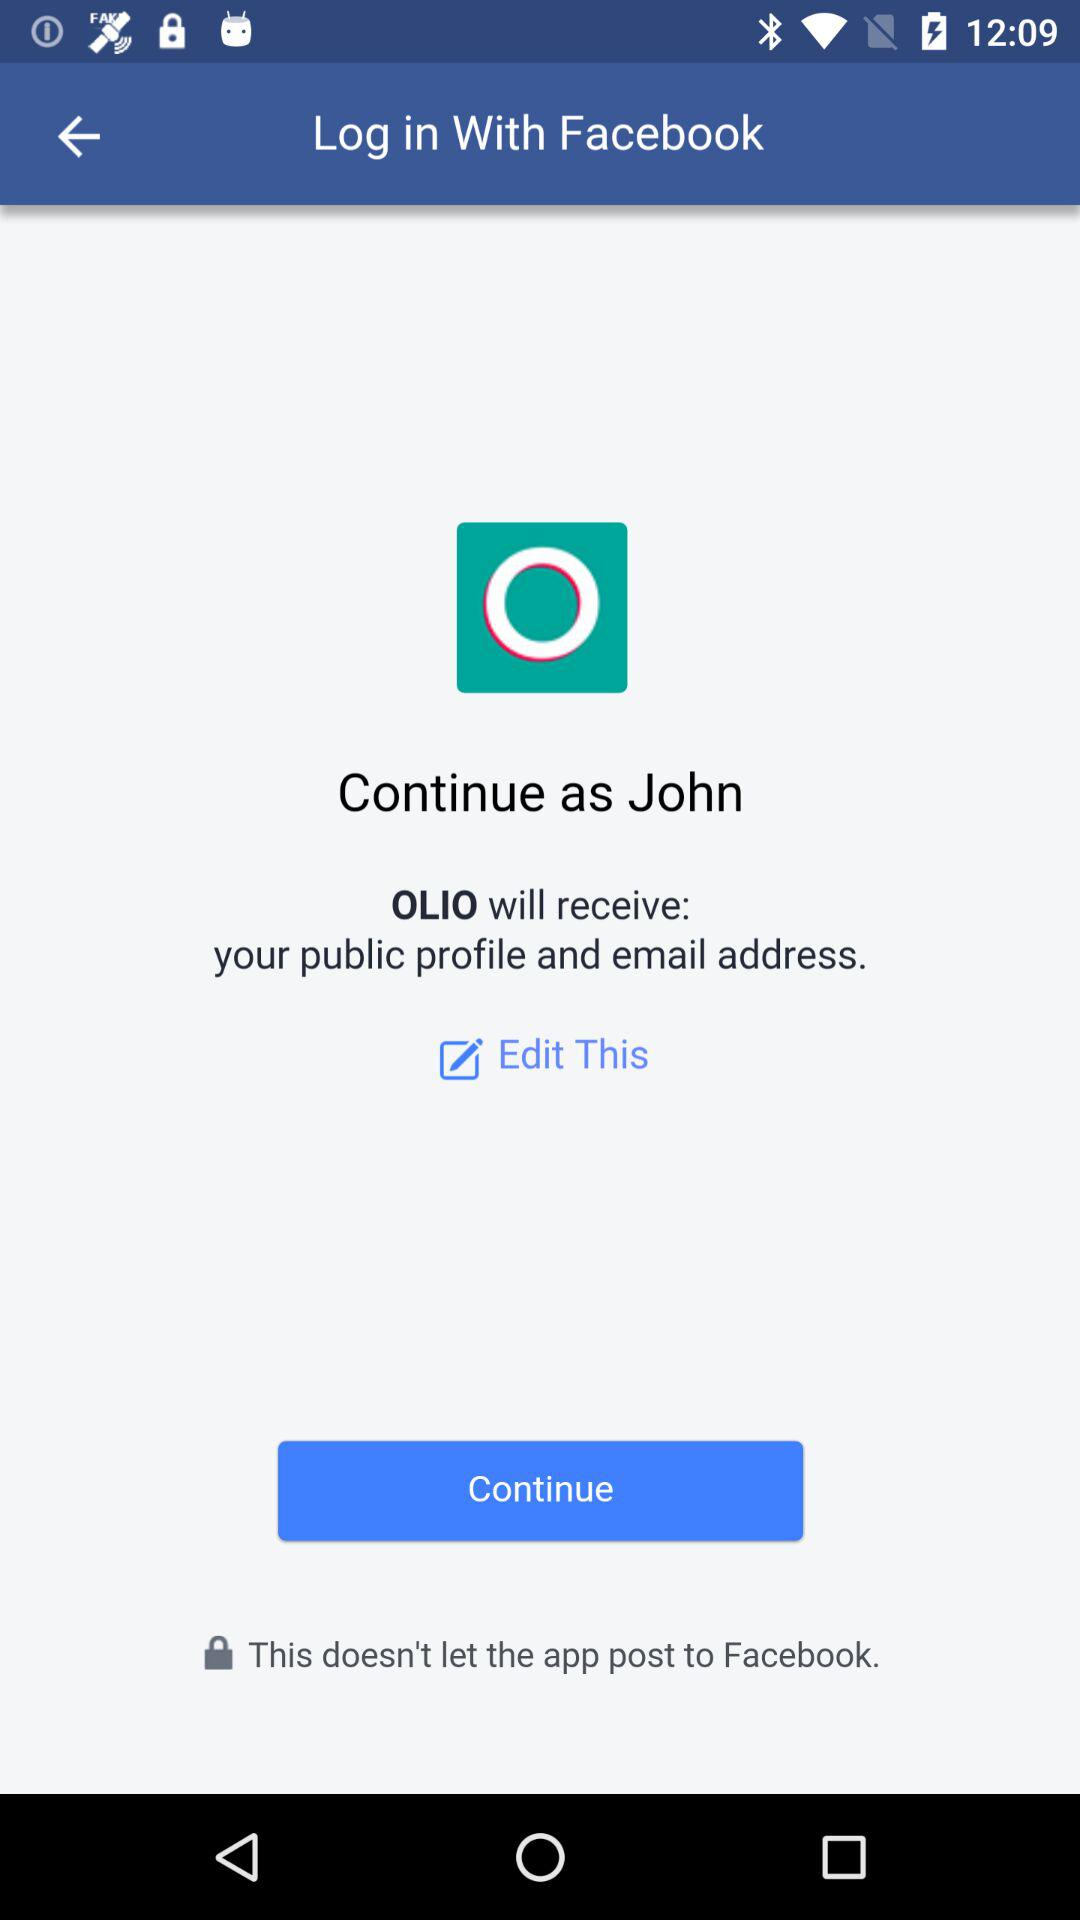What application will receive my public profile and email address? The application is "OLIO". 